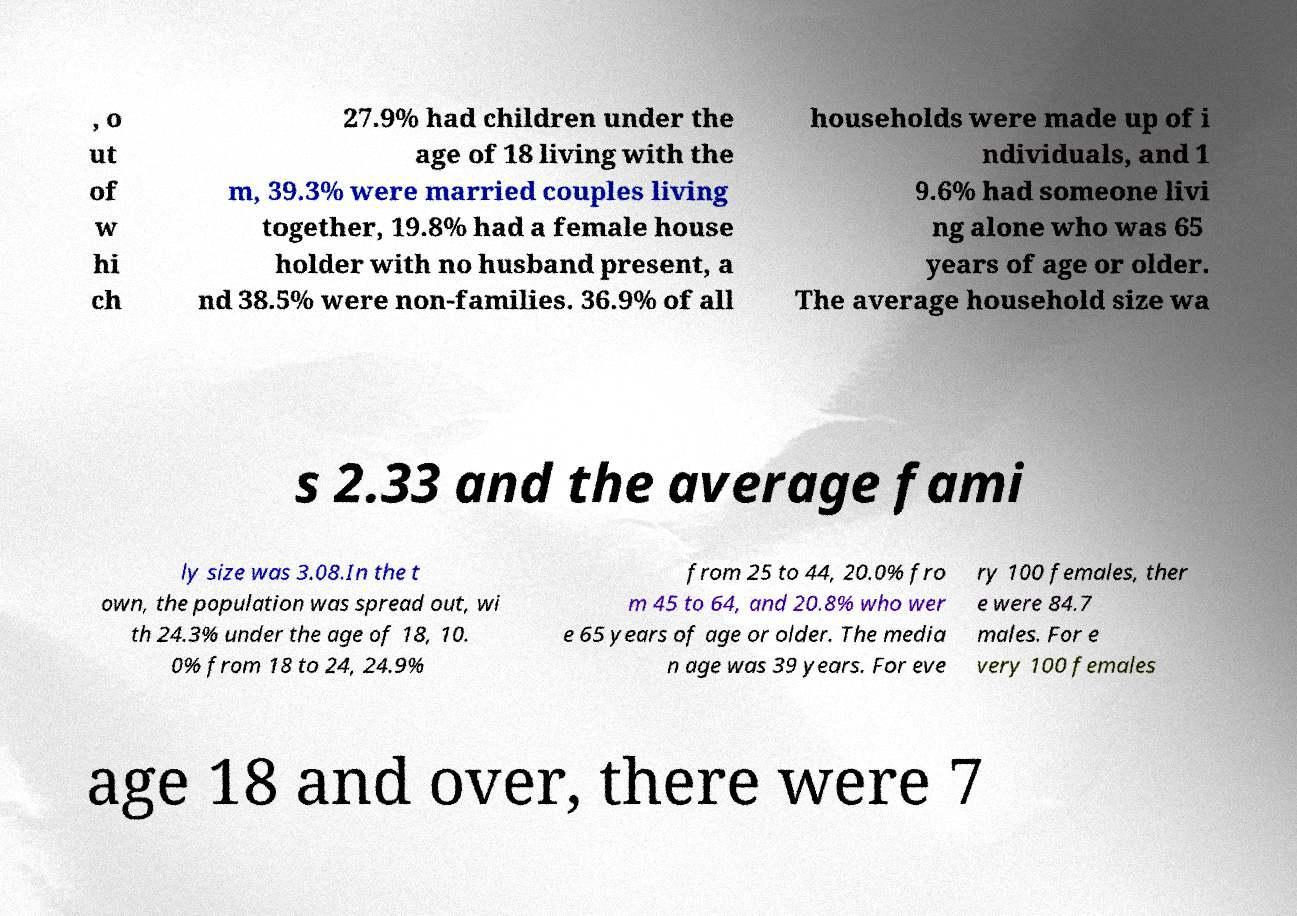Please read and relay the text visible in this image. What does it say? , o ut of w hi ch 27.9% had children under the age of 18 living with the m, 39.3% were married couples living together, 19.8% had a female house holder with no husband present, a nd 38.5% were non-families. 36.9% of all households were made up of i ndividuals, and 1 9.6% had someone livi ng alone who was 65 years of age or older. The average household size wa s 2.33 and the average fami ly size was 3.08.In the t own, the population was spread out, wi th 24.3% under the age of 18, 10. 0% from 18 to 24, 24.9% from 25 to 44, 20.0% fro m 45 to 64, and 20.8% who wer e 65 years of age or older. The media n age was 39 years. For eve ry 100 females, ther e were 84.7 males. For e very 100 females age 18 and over, there were 7 